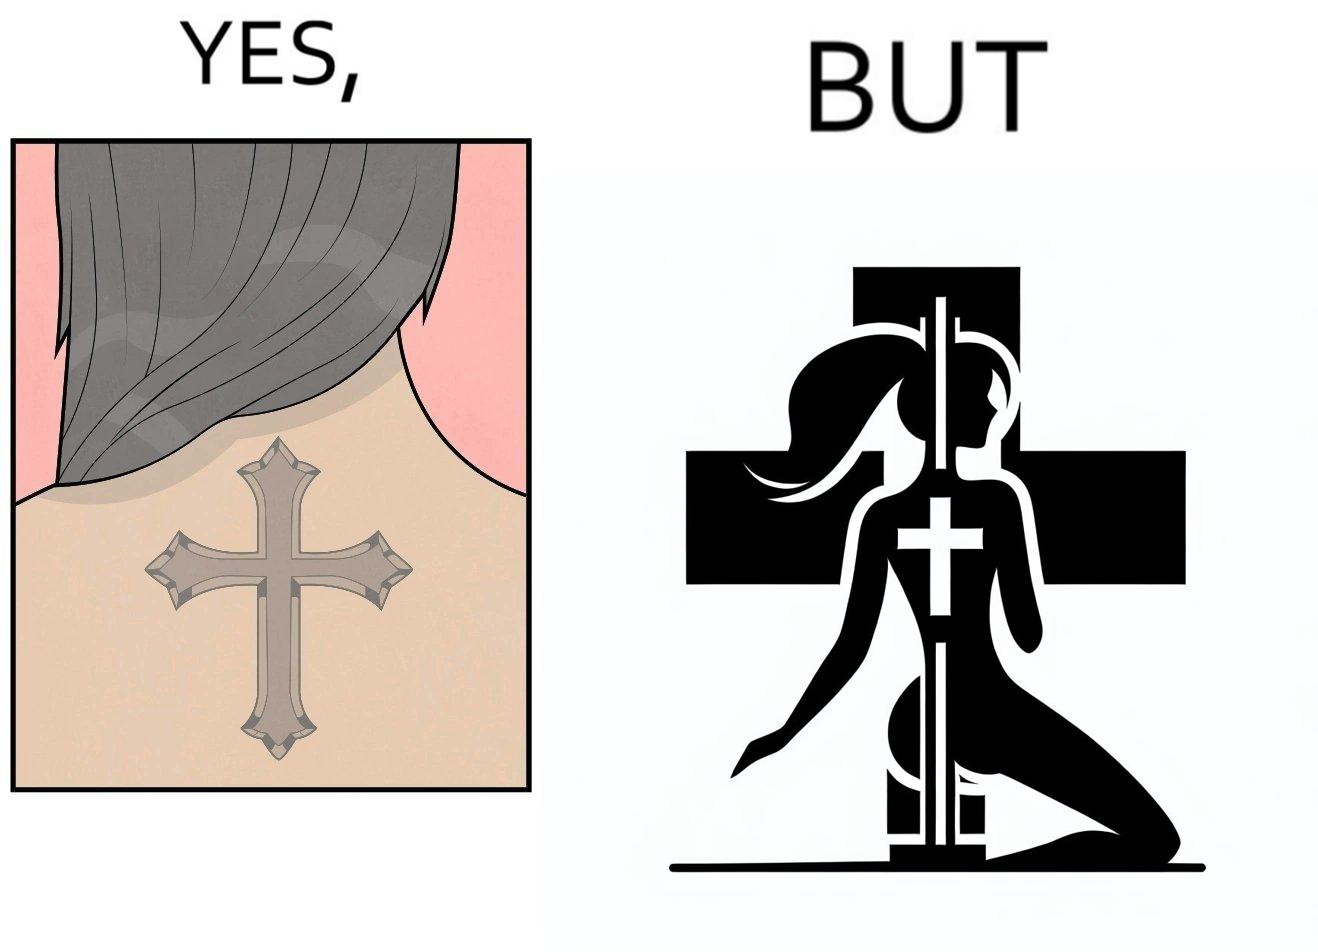What is the satirical meaning behind this image? This image may present two different ideas, firstly even she is such a believer in god that she has got a tatto of holy cross symbol on her back but her situations have forced her to do a job at a bar or some place performing pole dance and secondly she is using a religious symbol to glorify her look so that more people acknowledge her dance and give her some money 